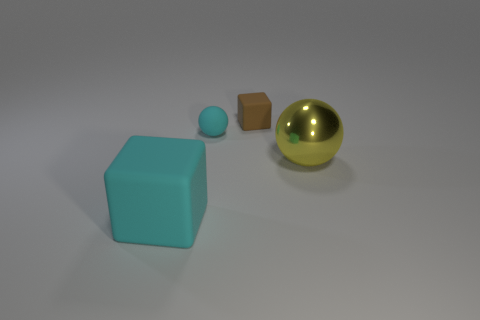Are there more small cyan objects that are left of the big yellow metal sphere than tiny brown rubber cubes right of the brown matte thing?
Provide a short and direct response. Yes. What number of other things are there of the same size as the metallic thing?
Offer a terse response. 1. What material is the thing that is to the right of the tiny ball and in front of the brown object?
Offer a very short reply. Metal. There is another object that is the same shape as the brown matte thing; what material is it?
Ensure brevity in your answer.  Rubber. There is a big matte object that is in front of the ball that is on the left side of the small rubber block; how many objects are behind it?
Make the answer very short. 3. Is there any other thing of the same color as the big block?
Keep it short and to the point. Yes. What number of objects are on the left side of the large yellow ball and to the right of the big rubber block?
Provide a succinct answer. 2. Does the cyan object behind the yellow thing have the same size as the block behind the yellow metal object?
Your answer should be very brief. Yes. What number of objects are matte objects on the right side of the big rubber thing or large gray matte spheres?
Make the answer very short. 2. What is the material of the sphere that is right of the tiny cyan ball?
Provide a short and direct response. Metal. 